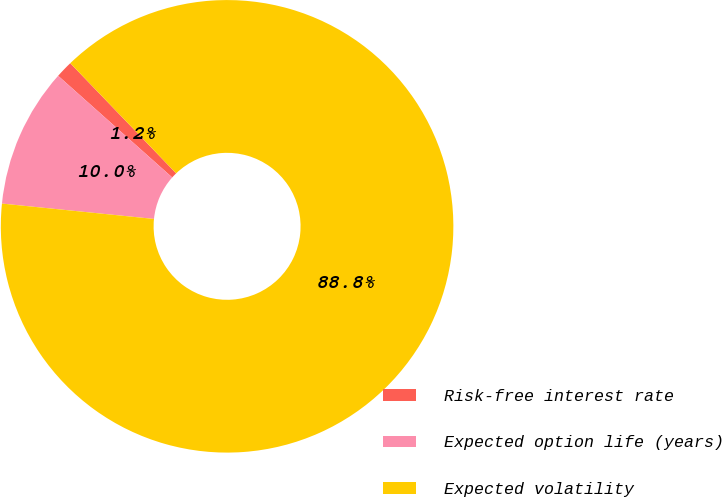<chart> <loc_0><loc_0><loc_500><loc_500><pie_chart><fcel>Risk-free interest rate<fcel>Expected option life (years)<fcel>Expected volatility<nl><fcel>1.23%<fcel>9.98%<fcel>88.78%<nl></chart> 